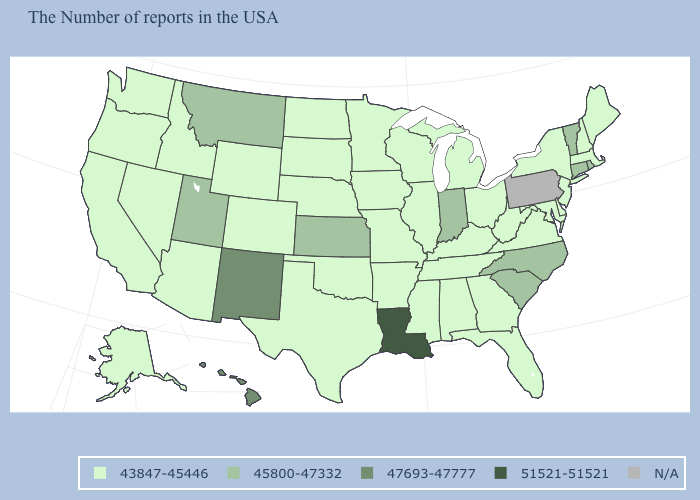What is the value of Ohio?
Quick response, please. 43847-45446. Name the states that have a value in the range 43847-45446?
Be succinct. Maine, Massachusetts, New Hampshire, New York, New Jersey, Delaware, Maryland, Virginia, West Virginia, Ohio, Florida, Georgia, Michigan, Kentucky, Alabama, Tennessee, Wisconsin, Illinois, Mississippi, Missouri, Arkansas, Minnesota, Iowa, Nebraska, Oklahoma, Texas, South Dakota, North Dakota, Wyoming, Colorado, Arizona, Idaho, Nevada, California, Washington, Oregon, Alaska. What is the value of New York?
Short answer required. 43847-45446. What is the value of Idaho?
Concise answer only. 43847-45446. Name the states that have a value in the range N/A?
Concise answer only. Pennsylvania. Is the legend a continuous bar?
Be succinct. No. Name the states that have a value in the range N/A?
Quick response, please. Pennsylvania. Does the first symbol in the legend represent the smallest category?
Keep it brief. Yes. Among the states that border Maryland , which have the lowest value?
Write a very short answer. Delaware, Virginia, West Virginia. Does Indiana have the highest value in the MidWest?
Keep it brief. Yes. Among the states that border Mississippi , which have the lowest value?
Answer briefly. Alabama, Tennessee, Arkansas. What is the lowest value in the USA?
Short answer required. 43847-45446. What is the value of Nevada?
Answer briefly. 43847-45446. 